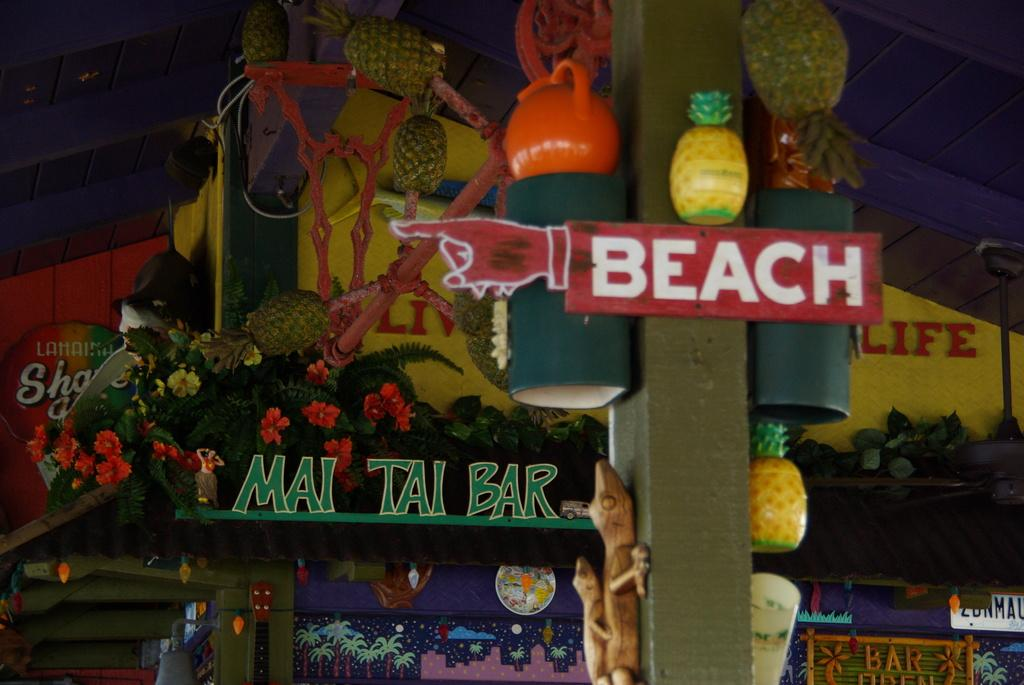<image>
Present a compact description of the photo's key features. A Mai Tai bar storefront has a sign that is shaped like a pointing finger that directs people to the beach in front of it. 